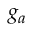Convert formula to latex. <formula><loc_0><loc_0><loc_500><loc_500>g _ { a }</formula> 